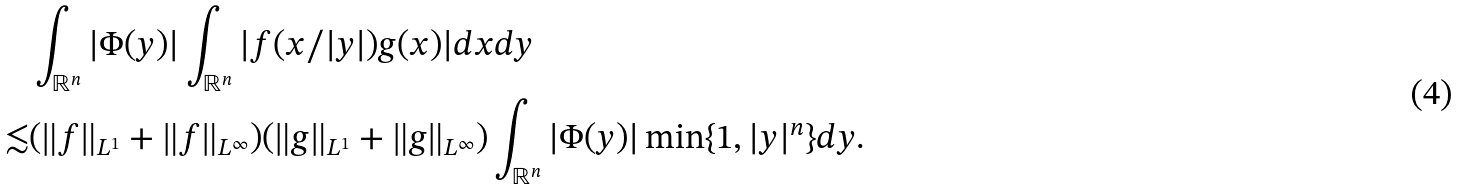<formula> <loc_0><loc_0><loc_500><loc_500>& \int _ { \mathbb { R } ^ { n } } | \Phi ( y ) | \int _ { \mathbb { R } ^ { n } } | f ( x / | y | ) g ( x ) | d x d y \\ \lesssim & ( \| f \| _ { L ^ { 1 } } + \| f \| _ { L ^ { \infty } } ) ( \| g \| _ { L ^ { 1 } } + \| g \| _ { L ^ { \infty } } ) \int _ { \mathbb { R } ^ { n } } | \Phi ( y ) | \min \{ 1 , | y | ^ { n } \} d y .</formula> 